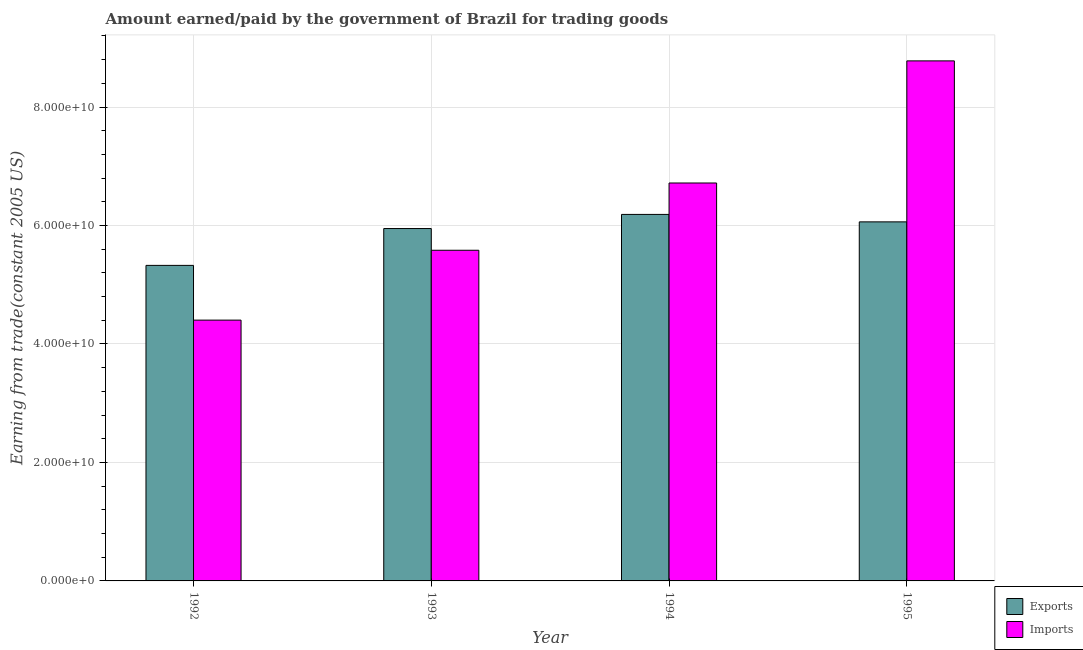How many different coloured bars are there?
Offer a terse response. 2. Are the number of bars per tick equal to the number of legend labels?
Your response must be concise. Yes. Are the number of bars on each tick of the X-axis equal?
Provide a short and direct response. Yes. How many bars are there on the 3rd tick from the left?
Keep it short and to the point. 2. How many bars are there on the 3rd tick from the right?
Ensure brevity in your answer.  2. What is the label of the 3rd group of bars from the left?
Your response must be concise. 1994. What is the amount earned from exports in 1994?
Your response must be concise. 6.19e+1. Across all years, what is the maximum amount earned from exports?
Provide a short and direct response. 6.19e+1. Across all years, what is the minimum amount earned from exports?
Your response must be concise. 5.33e+1. In which year was the amount paid for imports minimum?
Keep it short and to the point. 1992. What is the total amount earned from exports in the graph?
Keep it short and to the point. 2.35e+11. What is the difference between the amount paid for imports in 1992 and that in 1993?
Provide a short and direct response. -1.18e+1. What is the difference between the amount paid for imports in 1992 and the amount earned from exports in 1995?
Your answer should be compact. -4.38e+1. What is the average amount earned from exports per year?
Make the answer very short. 5.88e+1. In how many years, is the amount paid for imports greater than 16000000000 US$?
Provide a short and direct response. 4. What is the ratio of the amount paid for imports in 1992 to that in 1993?
Offer a very short reply. 0.79. What is the difference between the highest and the second highest amount earned from exports?
Keep it short and to the point. 1.26e+09. What is the difference between the highest and the lowest amount earned from exports?
Provide a short and direct response. 8.61e+09. In how many years, is the amount earned from exports greater than the average amount earned from exports taken over all years?
Give a very brief answer. 3. Is the sum of the amount paid for imports in 1993 and 1994 greater than the maximum amount earned from exports across all years?
Provide a succinct answer. Yes. What does the 1st bar from the left in 1994 represents?
Keep it short and to the point. Exports. What does the 2nd bar from the right in 1992 represents?
Keep it short and to the point. Exports. Are the values on the major ticks of Y-axis written in scientific E-notation?
Your answer should be very brief. Yes. Does the graph contain any zero values?
Your response must be concise. No. Where does the legend appear in the graph?
Your answer should be compact. Bottom right. What is the title of the graph?
Your answer should be compact. Amount earned/paid by the government of Brazil for trading goods. Does "Methane emissions" appear as one of the legend labels in the graph?
Your answer should be very brief. No. What is the label or title of the Y-axis?
Keep it short and to the point. Earning from trade(constant 2005 US). What is the Earning from trade(constant 2005 US) in Exports in 1992?
Offer a very short reply. 5.33e+1. What is the Earning from trade(constant 2005 US) in Imports in 1992?
Your answer should be compact. 4.40e+1. What is the Earning from trade(constant 2005 US) in Exports in 1993?
Keep it short and to the point. 5.95e+1. What is the Earning from trade(constant 2005 US) in Imports in 1993?
Ensure brevity in your answer.  5.58e+1. What is the Earning from trade(constant 2005 US) in Exports in 1994?
Provide a short and direct response. 6.19e+1. What is the Earning from trade(constant 2005 US) in Imports in 1994?
Offer a very short reply. 6.72e+1. What is the Earning from trade(constant 2005 US) of Exports in 1995?
Ensure brevity in your answer.  6.06e+1. What is the Earning from trade(constant 2005 US) of Imports in 1995?
Give a very brief answer. 8.78e+1. Across all years, what is the maximum Earning from trade(constant 2005 US) in Exports?
Your answer should be very brief. 6.19e+1. Across all years, what is the maximum Earning from trade(constant 2005 US) in Imports?
Make the answer very short. 8.78e+1. Across all years, what is the minimum Earning from trade(constant 2005 US) of Exports?
Ensure brevity in your answer.  5.33e+1. Across all years, what is the minimum Earning from trade(constant 2005 US) in Imports?
Offer a terse response. 4.40e+1. What is the total Earning from trade(constant 2005 US) of Exports in the graph?
Your response must be concise. 2.35e+11. What is the total Earning from trade(constant 2005 US) of Imports in the graph?
Provide a short and direct response. 2.55e+11. What is the difference between the Earning from trade(constant 2005 US) of Exports in 1992 and that in 1993?
Your response must be concise. -6.22e+09. What is the difference between the Earning from trade(constant 2005 US) of Imports in 1992 and that in 1993?
Give a very brief answer. -1.18e+1. What is the difference between the Earning from trade(constant 2005 US) of Exports in 1992 and that in 1994?
Your response must be concise. -8.61e+09. What is the difference between the Earning from trade(constant 2005 US) in Imports in 1992 and that in 1994?
Your answer should be very brief. -2.31e+1. What is the difference between the Earning from trade(constant 2005 US) in Exports in 1992 and that in 1995?
Make the answer very short. -7.35e+09. What is the difference between the Earning from trade(constant 2005 US) in Imports in 1992 and that in 1995?
Give a very brief answer. -4.38e+1. What is the difference between the Earning from trade(constant 2005 US) in Exports in 1993 and that in 1994?
Your answer should be compact. -2.38e+09. What is the difference between the Earning from trade(constant 2005 US) in Imports in 1993 and that in 1994?
Provide a succinct answer. -1.14e+1. What is the difference between the Earning from trade(constant 2005 US) of Exports in 1993 and that in 1995?
Make the answer very short. -1.13e+09. What is the difference between the Earning from trade(constant 2005 US) of Imports in 1993 and that in 1995?
Make the answer very short. -3.20e+1. What is the difference between the Earning from trade(constant 2005 US) in Exports in 1994 and that in 1995?
Ensure brevity in your answer.  1.26e+09. What is the difference between the Earning from trade(constant 2005 US) of Imports in 1994 and that in 1995?
Your answer should be very brief. -2.06e+1. What is the difference between the Earning from trade(constant 2005 US) of Exports in 1992 and the Earning from trade(constant 2005 US) of Imports in 1993?
Make the answer very short. -2.55e+09. What is the difference between the Earning from trade(constant 2005 US) of Exports in 1992 and the Earning from trade(constant 2005 US) of Imports in 1994?
Your answer should be compact. -1.39e+1. What is the difference between the Earning from trade(constant 2005 US) of Exports in 1992 and the Earning from trade(constant 2005 US) of Imports in 1995?
Your answer should be compact. -3.45e+1. What is the difference between the Earning from trade(constant 2005 US) of Exports in 1993 and the Earning from trade(constant 2005 US) of Imports in 1994?
Ensure brevity in your answer.  -7.69e+09. What is the difference between the Earning from trade(constant 2005 US) in Exports in 1993 and the Earning from trade(constant 2005 US) in Imports in 1995?
Your answer should be compact. -2.83e+1. What is the difference between the Earning from trade(constant 2005 US) of Exports in 1994 and the Earning from trade(constant 2005 US) of Imports in 1995?
Your response must be concise. -2.59e+1. What is the average Earning from trade(constant 2005 US) of Exports per year?
Provide a short and direct response. 5.88e+1. What is the average Earning from trade(constant 2005 US) in Imports per year?
Ensure brevity in your answer.  6.37e+1. In the year 1992, what is the difference between the Earning from trade(constant 2005 US) in Exports and Earning from trade(constant 2005 US) in Imports?
Provide a short and direct response. 9.24e+09. In the year 1993, what is the difference between the Earning from trade(constant 2005 US) in Exports and Earning from trade(constant 2005 US) in Imports?
Offer a terse response. 3.67e+09. In the year 1994, what is the difference between the Earning from trade(constant 2005 US) of Exports and Earning from trade(constant 2005 US) of Imports?
Offer a terse response. -5.30e+09. In the year 1995, what is the difference between the Earning from trade(constant 2005 US) of Exports and Earning from trade(constant 2005 US) of Imports?
Your answer should be very brief. -2.72e+1. What is the ratio of the Earning from trade(constant 2005 US) of Exports in 1992 to that in 1993?
Offer a very short reply. 0.9. What is the ratio of the Earning from trade(constant 2005 US) in Imports in 1992 to that in 1993?
Offer a terse response. 0.79. What is the ratio of the Earning from trade(constant 2005 US) of Exports in 1992 to that in 1994?
Keep it short and to the point. 0.86. What is the ratio of the Earning from trade(constant 2005 US) of Imports in 1992 to that in 1994?
Give a very brief answer. 0.66. What is the ratio of the Earning from trade(constant 2005 US) in Exports in 1992 to that in 1995?
Offer a very short reply. 0.88. What is the ratio of the Earning from trade(constant 2005 US) of Imports in 1992 to that in 1995?
Make the answer very short. 0.5. What is the ratio of the Earning from trade(constant 2005 US) in Exports in 1993 to that in 1994?
Ensure brevity in your answer.  0.96. What is the ratio of the Earning from trade(constant 2005 US) in Imports in 1993 to that in 1994?
Provide a short and direct response. 0.83. What is the ratio of the Earning from trade(constant 2005 US) of Exports in 1993 to that in 1995?
Keep it short and to the point. 0.98. What is the ratio of the Earning from trade(constant 2005 US) of Imports in 1993 to that in 1995?
Ensure brevity in your answer.  0.64. What is the ratio of the Earning from trade(constant 2005 US) in Exports in 1994 to that in 1995?
Provide a succinct answer. 1.02. What is the ratio of the Earning from trade(constant 2005 US) of Imports in 1994 to that in 1995?
Your answer should be compact. 0.77. What is the difference between the highest and the second highest Earning from trade(constant 2005 US) of Exports?
Ensure brevity in your answer.  1.26e+09. What is the difference between the highest and the second highest Earning from trade(constant 2005 US) of Imports?
Provide a succinct answer. 2.06e+1. What is the difference between the highest and the lowest Earning from trade(constant 2005 US) of Exports?
Make the answer very short. 8.61e+09. What is the difference between the highest and the lowest Earning from trade(constant 2005 US) of Imports?
Your answer should be very brief. 4.38e+1. 